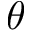<formula> <loc_0><loc_0><loc_500><loc_500>\theta</formula> 